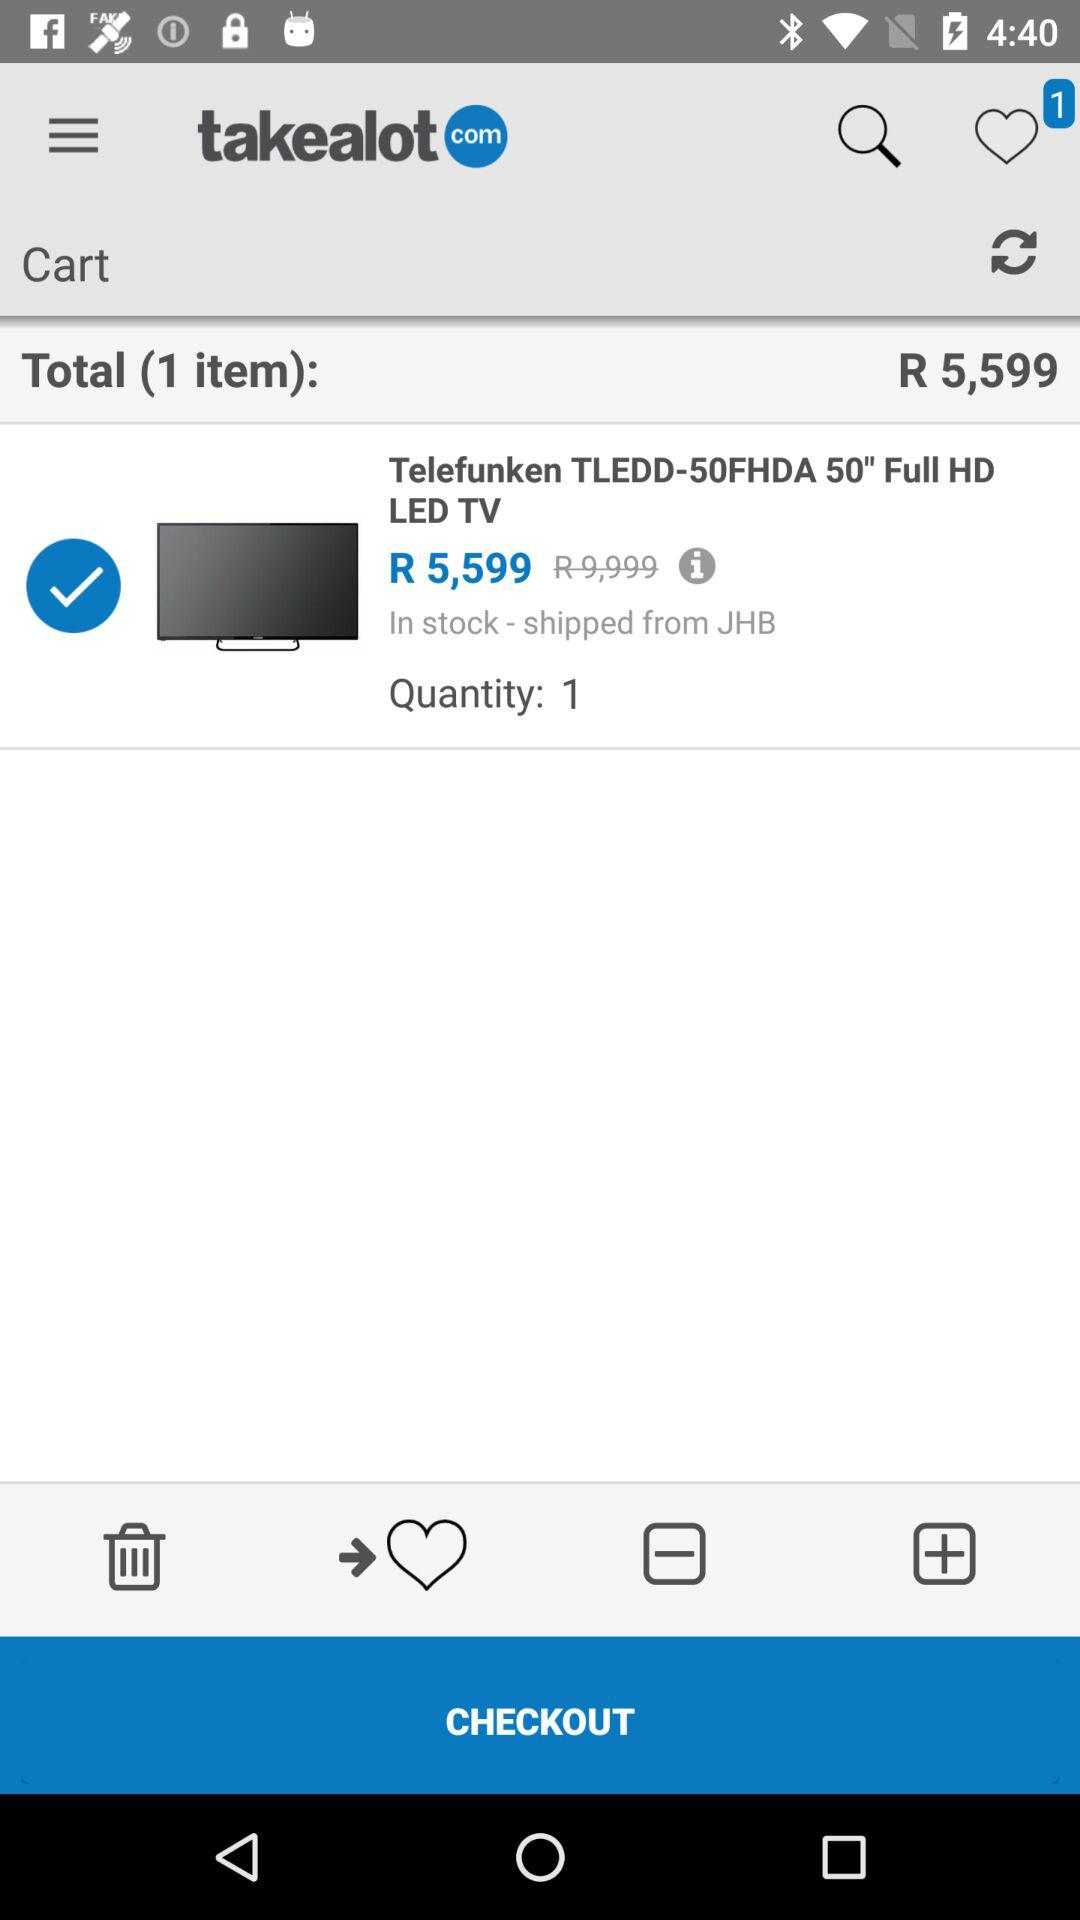What is the name of the item bought? The name of the item is "Telefunken TLEDD-50FHDA 50" FULL HD LED TV". 